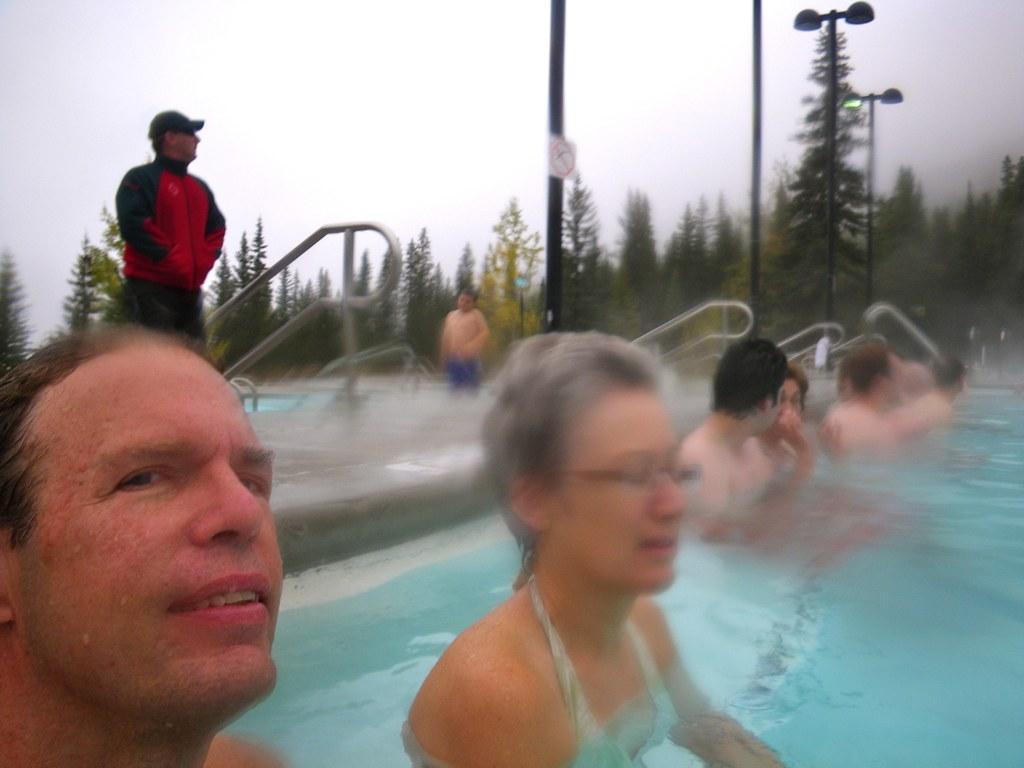Please provide a concise description of this image. In this picture we can see some people are in the water and few people are standing outside and watching, around we can see some trees. 